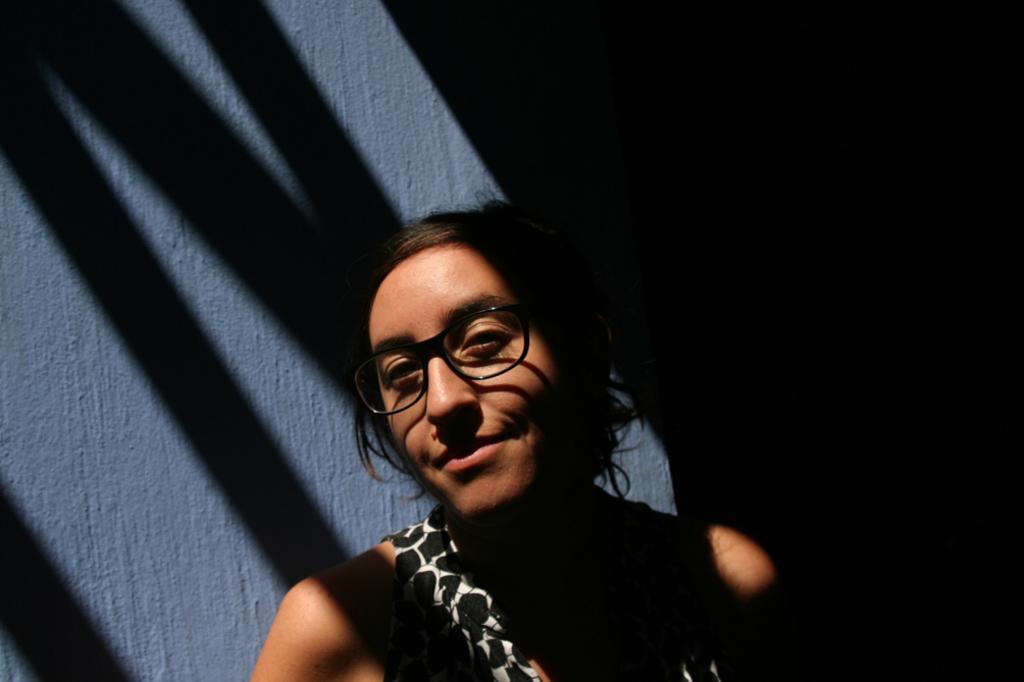How would you summarize this image in a sentence or two? This image is taken in dark where we can see a person wearing dress and spectacles is standing near the grey color wall. 